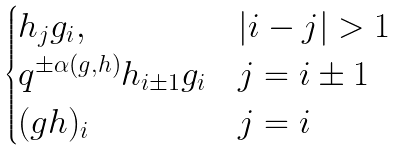<formula> <loc_0><loc_0><loc_500><loc_500>\begin{cases} h _ { j } g _ { i } , & | i - j | > 1 \\ q ^ { \pm \alpha ( g , h ) } h _ { i \pm 1 } g _ { i } & j = i \pm 1 \\ ( g h ) _ { i } & j = i \end{cases}</formula> 